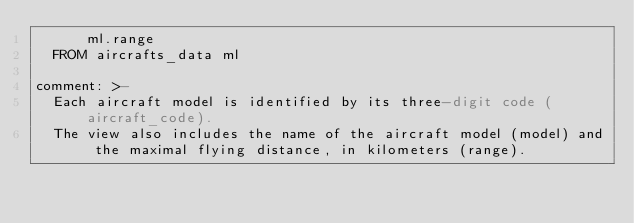Convert code to text. <code><loc_0><loc_0><loc_500><loc_500><_YAML_>      ml.range
  FROM aircrafts_data ml

comment: >-
  Each aircraft model is identified by its three-digit code (aircraft_code).
  The view also includes the name of the aircraft model (model) and the maximal flying distance, in kilometers (range).
</code> 